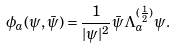Convert formula to latex. <formula><loc_0><loc_0><loc_500><loc_500>\phi _ { a } ( \psi , \bar { \psi } ) = \frac { 1 } { | \psi | ^ { 2 } } \bar { \psi } \Lambda _ { a } ^ { ( \frac { 1 } { 2 } ) } \psi .</formula> 